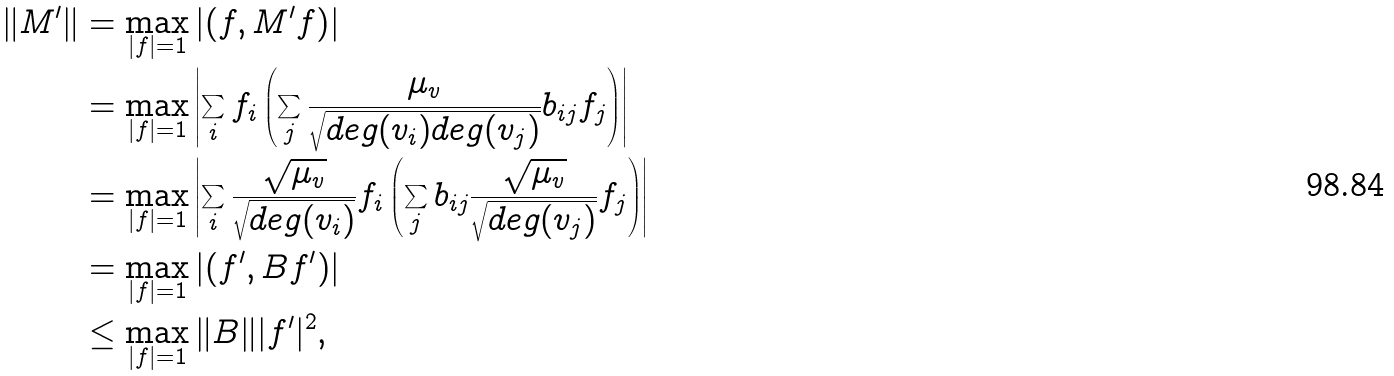<formula> <loc_0><loc_0><loc_500><loc_500>\| M ^ { \prime } \| & = \max _ { | f | = 1 } \left | \left ( f , M ^ { \prime } f \right ) \right | \\ & = \max _ { | f | = 1 } \left | \sum _ { i } f _ { i } \left ( \sum _ { j } \frac { \mu _ { v } } { \sqrt { d e g ( v _ { i } ) d e g ( v _ { j } ) } } b _ { i j } f _ { j } \right ) \right | \\ & = \max _ { | f | = 1 } \left | \sum _ { i } \frac { \sqrt { \mu _ { v } } } { \sqrt { d e g ( v _ { i } ) } } f _ { i } \left ( \sum _ { j } b _ { i j } \frac { \sqrt { \mu _ { v } } } { \sqrt { d e g ( v _ { j } ) } } f _ { j } \right ) \right | \\ & = \max _ { | f | = 1 } \left | \left ( f ^ { \prime } , B f ^ { \prime } \right ) \right | \\ & \leq \max _ { | f | = 1 } \| B \| | f ^ { \prime } | ^ { 2 } ,</formula> 